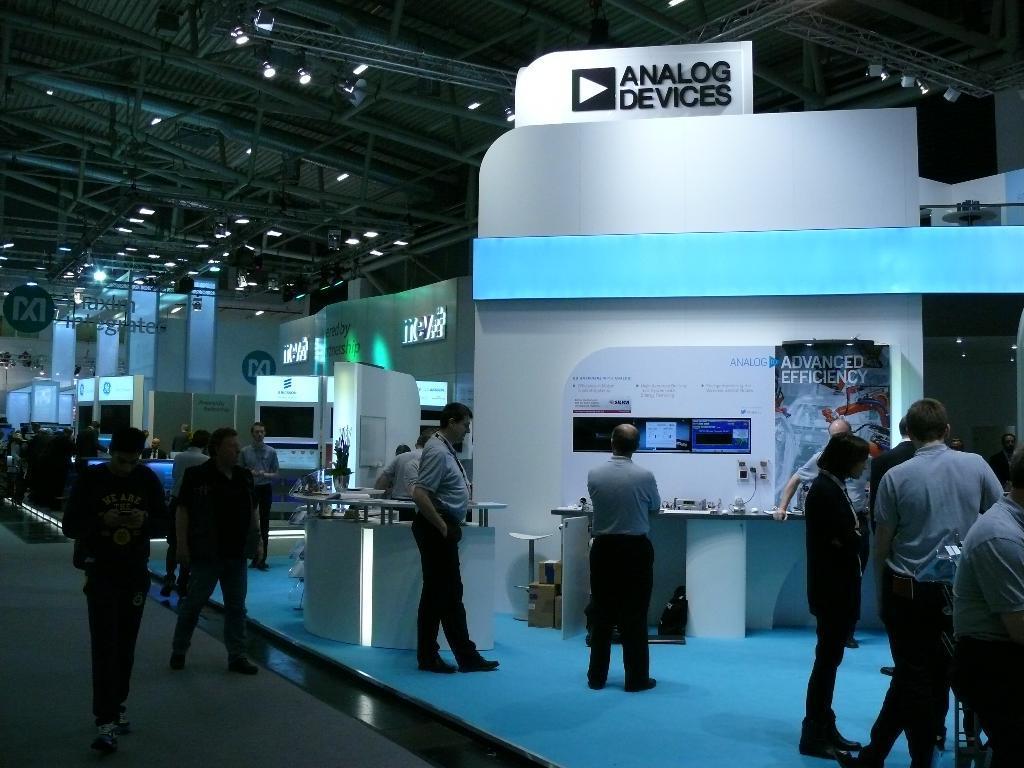Could you give a brief overview of what you see in this image? In this image, we can see people on the floor and in the background, there are some objects on the stand and we can see a poster on the wall, with some text and there are screens, boards and we can see lights. At the top, there is a roof. 